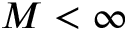Convert formula to latex. <formula><loc_0><loc_0><loc_500><loc_500>M < \infty</formula> 